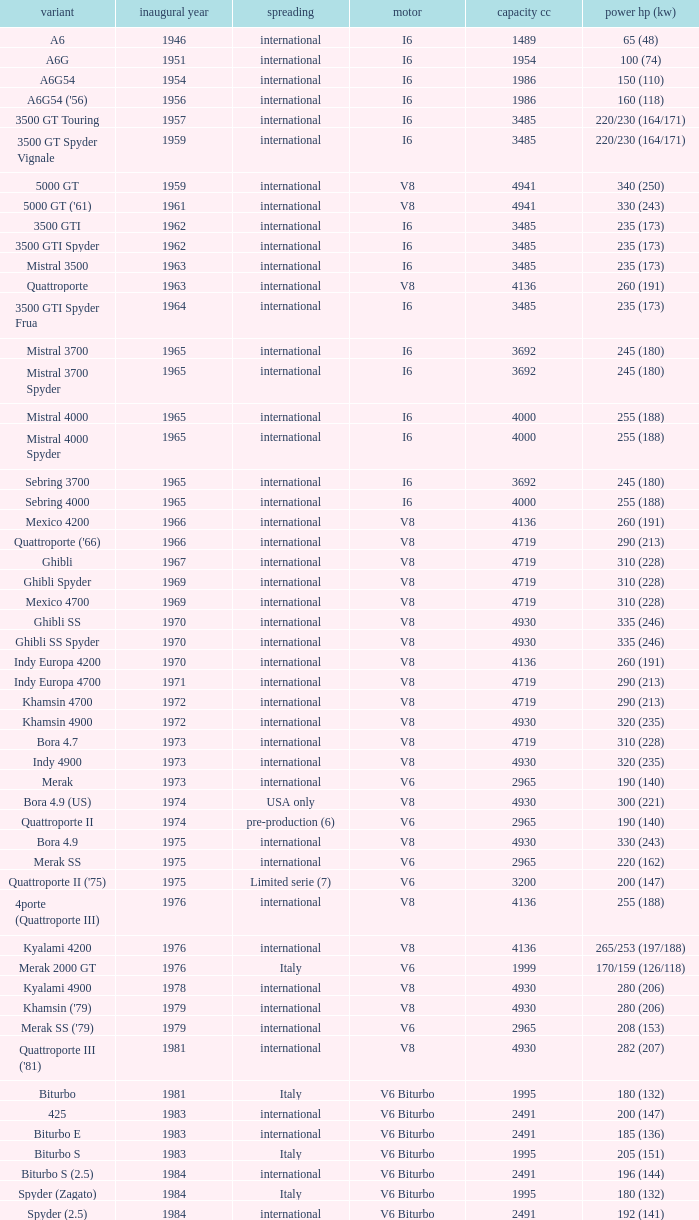What is the total number of First Year, when Displacement CC is greater than 4719, when Engine is V8, when Power HP (kW) is "335 (246)", and when Model is "Ghibli SS"? 1.0. 